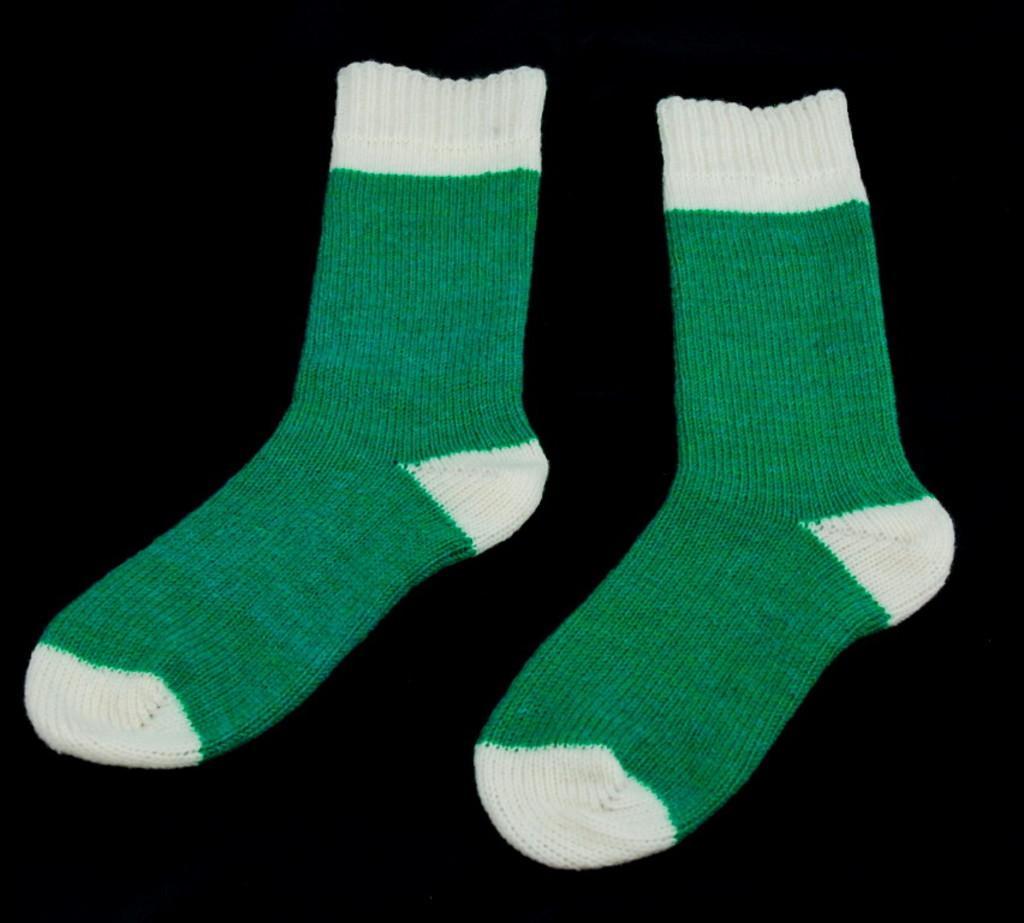How would you summarize this image in a sentence or two? In this image, we can see two green and white color socks. 